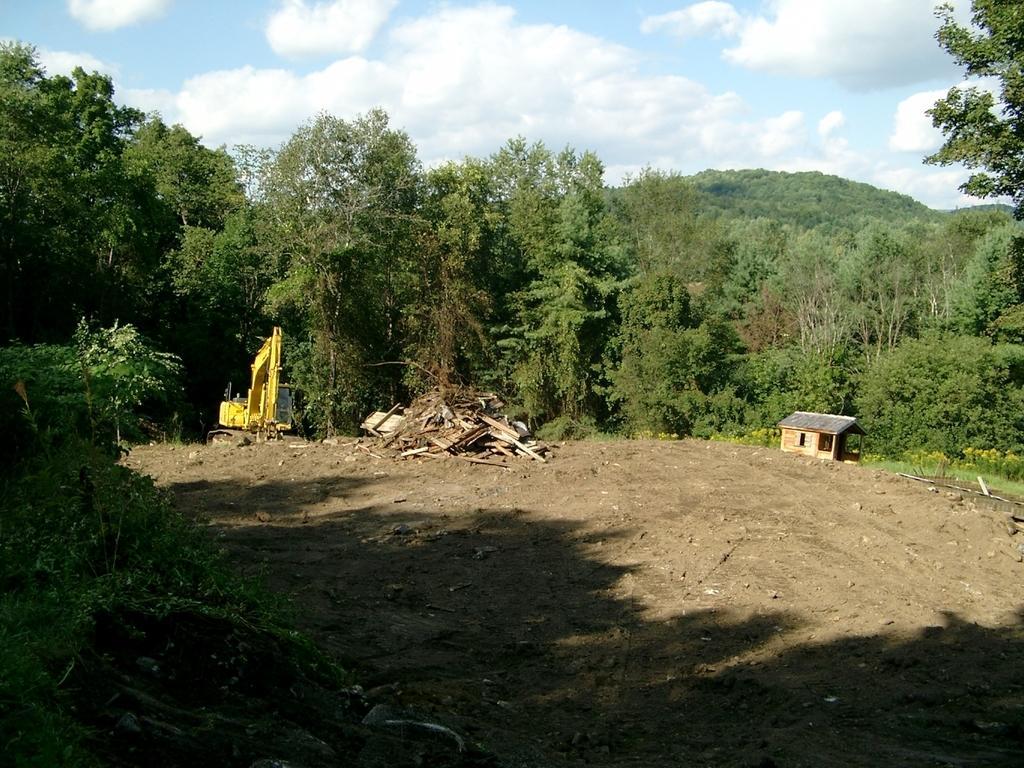Can you describe this image briefly? On the left side, there are plants on the ground. In the background, there is an excavator, woods, a shelter, there are trees, plants and grass on the ground, there is a mountain and there are clouds in the sky. 